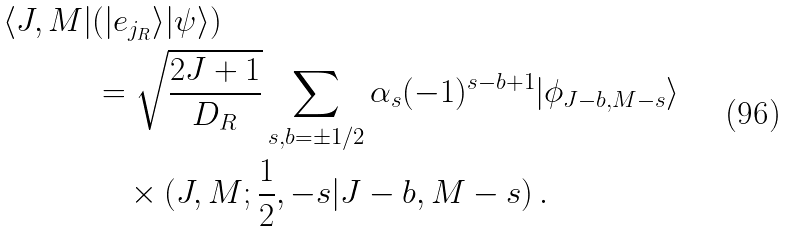<formula> <loc_0><loc_0><loc_500><loc_500>\langle J , M | & ( | e _ { j _ { R } } \rangle | \psi \rangle ) \\ & = \sqrt { \frac { 2 J + 1 } { D _ { R } } } \sum _ { s , b = \pm 1 / 2 } \alpha _ { s } ( - 1 ) ^ { s - b + 1 } | \phi _ { J - b , M - s } \rangle \\ & \quad \times ( J , M ; \frac { 1 } { 2 } , - s | J - b , M - s ) \, .</formula> 